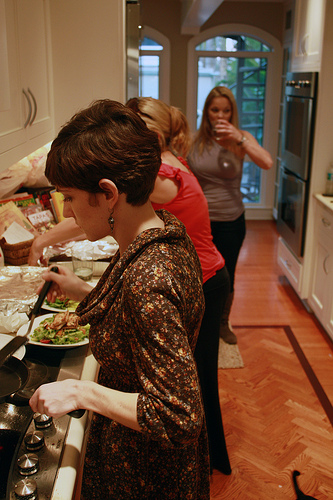Please provide the bounding box coordinate of the region this sentence describes: a rug on the floor. [0.6, 0.64, 0.65, 0.74]. This coordinates focus on a rug placed on the floor, adding to the decor. 